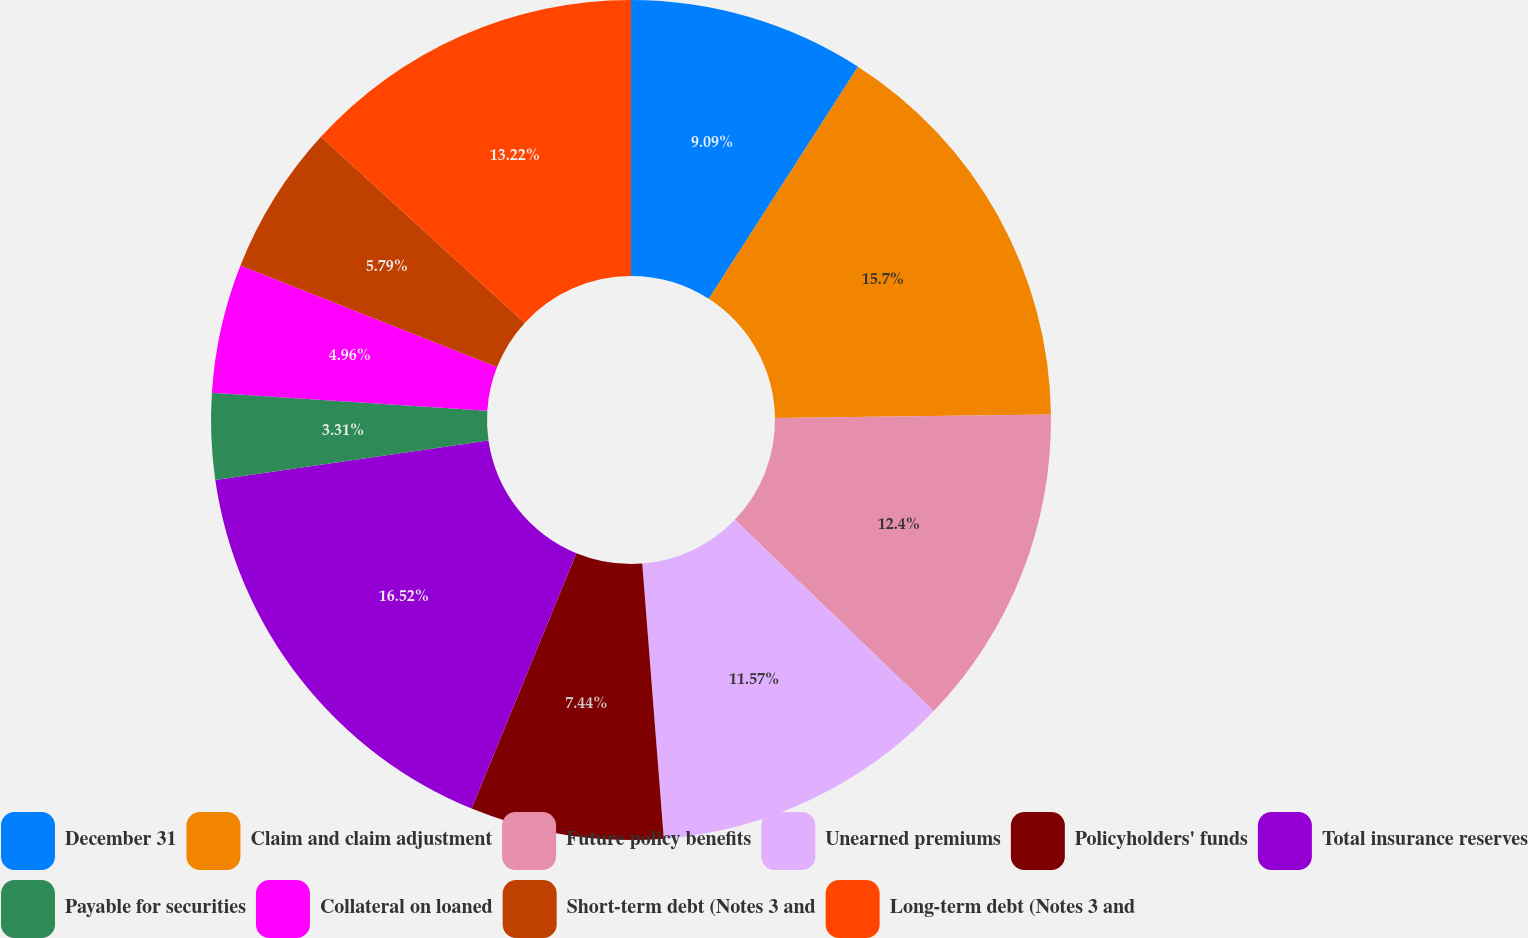<chart> <loc_0><loc_0><loc_500><loc_500><pie_chart><fcel>December 31<fcel>Claim and claim adjustment<fcel>Future policy benefits<fcel>Unearned premiums<fcel>Policyholders' funds<fcel>Total insurance reserves<fcel>Payable for securities<fcel>Collateral on loaned<fcel>Short-term debt (Notes 3 and<fcel>Long-term debt (Notes 3 and<nl><fcel>9.09%<fcel>15.7%<fcel>12.4%<fcel>11.57%<fcel>7.44%<fcel>16.53%<fcel>3.31%<fcel>4.96%<fcel>5.79%<fcel>13.22%<nl></chart> 